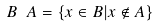<formula> <loc_0><loc_0><loc_500><loc_500>B \ A = \{ x \in B | x \notin A \}</formula> 